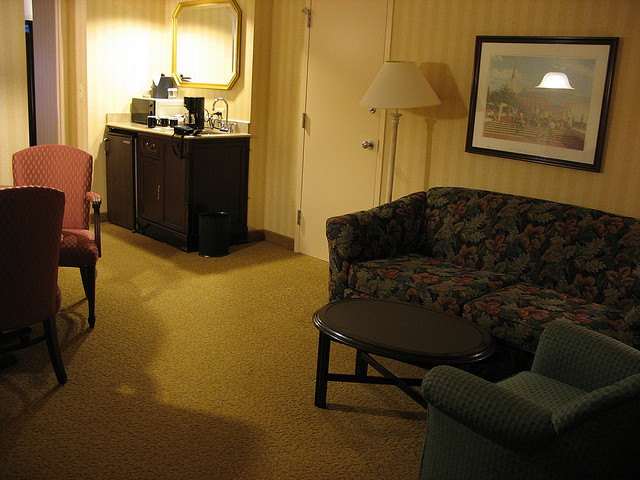<image>Which seat would be the least comfortable? It's ambiguous which seat would be the least comfortable. Which seat would be the least comfortable? I don't know which seat would be the least comfortable. It can be any of the chairs or the table. 